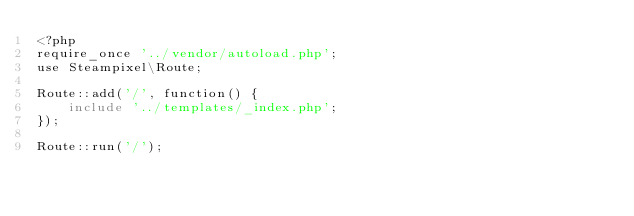<code> <loc_0><loc_0><loc_500><loc_500><_PHP_><?php
require_once '../vendor/autoload.php';
use Steampixel\Route;

Route::add('/', function() {
    include '../templates/_index.php';
});

Route::run('/');</code> 